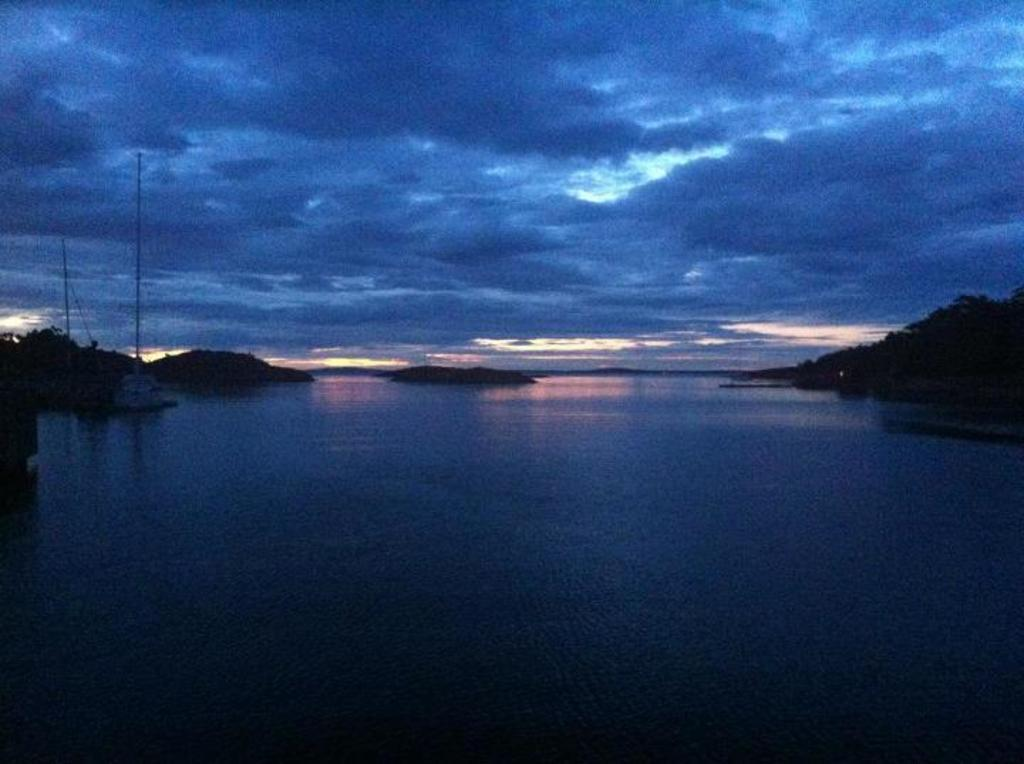What is the main subject of the image? The main subject of the image is a boat. Where is the boat located? The boat is on the water. What else can be seen in the image besides the boat? There are poles, mountains, and clouds visible in the image. What type of wax is being used to create the army in the image? There is no army or wax present in the image. 